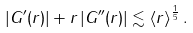<formula> <loc_0><loc_0><loc_500><loc_500>| G ^ { \prime } ( r ) | + r \, | G ^ { \prime \prime } ( r ) | \lesssim \langle r \rangle ^ { \frac { 1 } { 5 } } \, .</formula> 